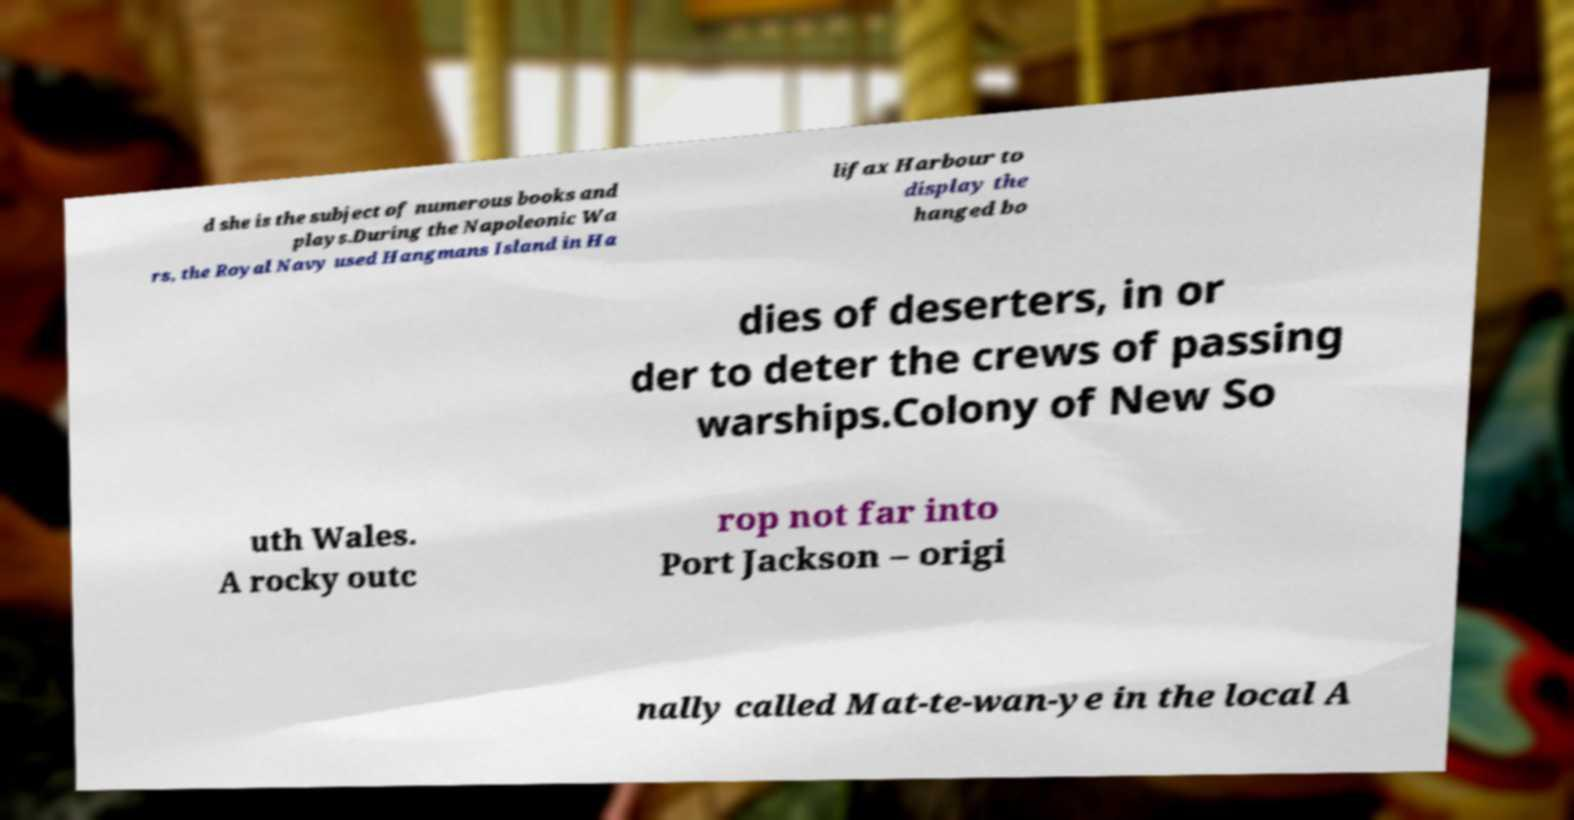I need the written content from this picture converted into text. Can you do that? d she is the subject of numerous books and plays.During the Napoleonic Wa rs, the Royal Navy used Hangmans Island in Ha lifax Harbour to display the hanged bo dies of deserters, in or der to deter the crews of passing warships.Colony of New So uth Wales. A rocky outc rop not far into Port Jackson – origi nally called Mat-te-wan-ye in the local A 